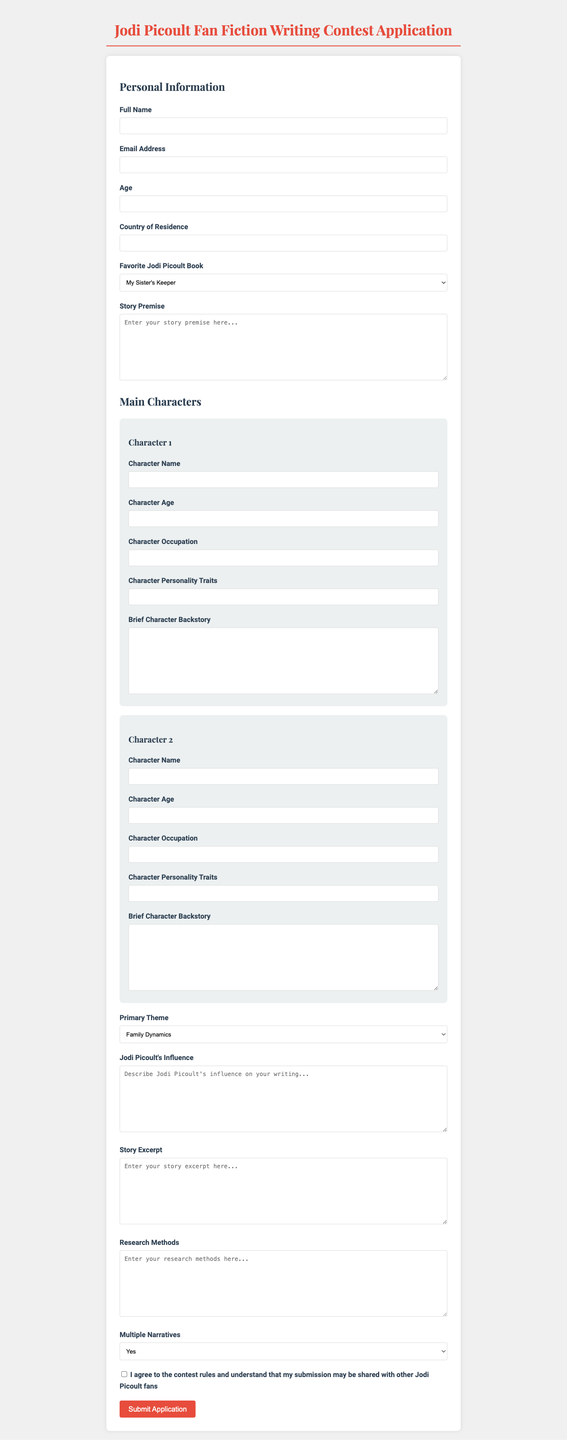What is the title of the application form? The title provided at the top of the form is a key piece of information.
Answer: Jodi Picoult Fan Fiction Writing Contest Application What age is required for the application? The document includes a section requesting the applicant's age, indicating it must be filled out.
Answer: Required What is an option for the favorite Jodi Picoult book? This item includes a list of choices available in the dropdown menu for favorites.
Answer: My Sister's Keeper How many main characters can be described in the application? The section for main characters lists two separate character entries.
Answer: Two What is the maximum word count for the story premise? The document has a specific limit for the story premise to ensure conciseness.
Answer: 500 words What themes are selectable for the story? The list of themes indicates the range of topics that can be chosen for the story.
Answer: Family Dynamics Is a checkbox required for terms and conditions? This question addresses a mandatory part of the application process indicated by a checkbox.
Answer: Yes How long can the story excerpt be? This is specified to manage the length of the included story excerpt in the application.
Answer: 1000 words Will the story feature multiple narratives or perspectives? This question addresses the narrative structure choice given as an option on the form.
Answer: Yes, No, Undecided 